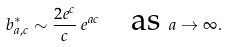Convert formula to latex. <formula><loc_0><loc_0><loc_500><loc_500>b ^ { * } _ { a , c } \sim \frac { 2 e ^ { c } } c \, e ^ { a c } \quad \text {as } a \to \infty .</formula> 